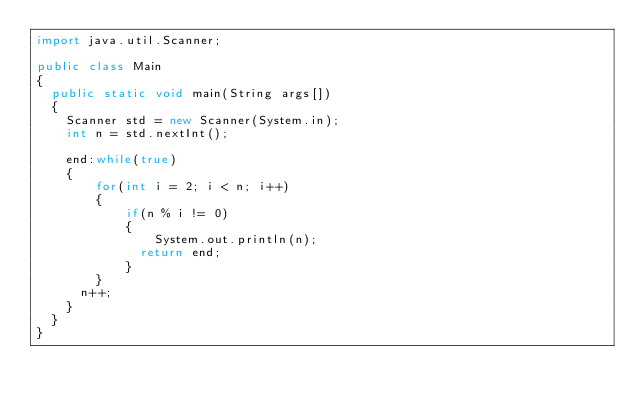<code> <loc_0><loc_0><loc_500><loc_500><_Java_>import java.util.Scanner;
 
public class Main
{
  public static void main(String args[])
  {
    Scanner std = new Scanner(System.in);
    int n = std.nextInt();
    
    end:while(true)
    {
        for(int i = 2; i < n; i++)
    	{
      		if(n % i != 0)
      		{
        		System.out.println(n);
              return end;
      		}
    	}
      n++;
    }
  }
}</code> 